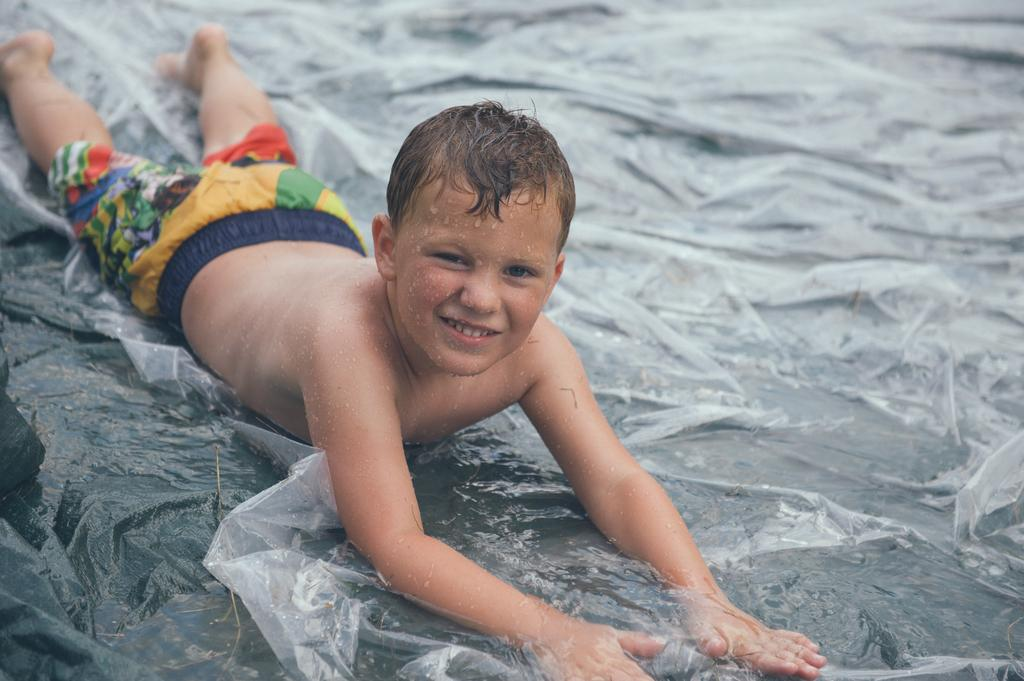Where was the image most likely taken? The image was likely clicked outside. What is the person in the image doing? The person is lying on an object in the image. Can you describe the person's physical condition in the image? Droplets of water are visible on the person's body. What else can be seen in the image besides the person and the object? There are other unspecified objects in the image. What type of brain is visible in the image? There is no brain visible in the image. What nation is represented by the person in the image? The image does not provide any information about the person's nationality or the nation they represent. 